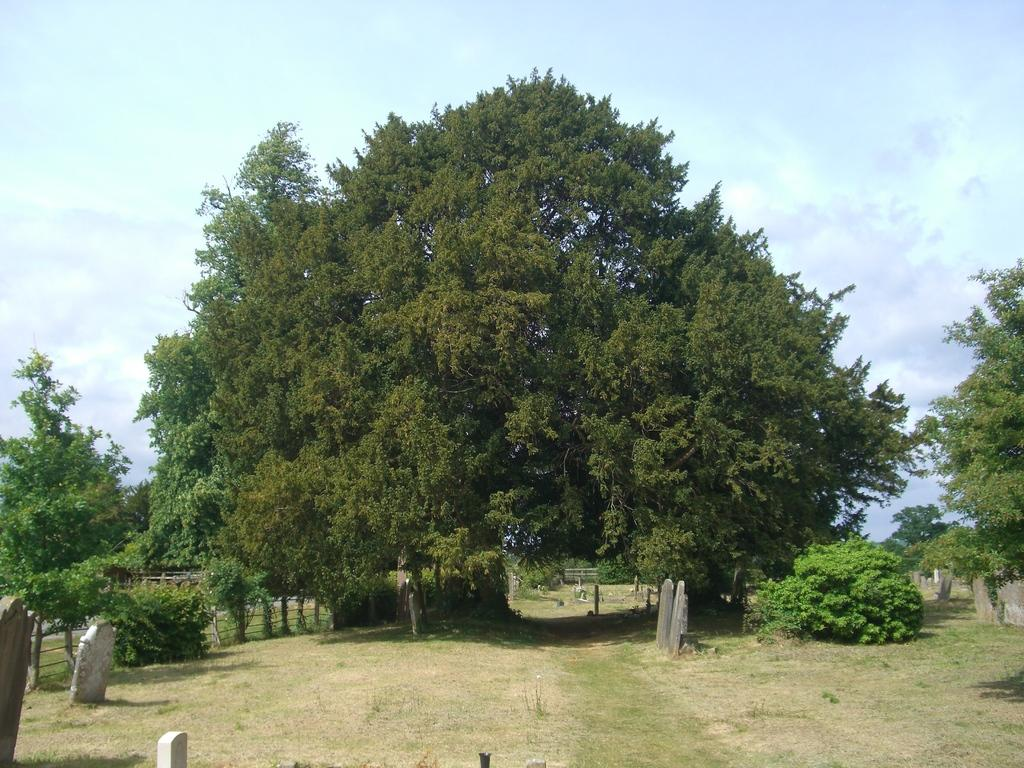What type of natural elements can be seen in the image? There are trees and plants in the image. What objects in the image resemble gravestones? There are stones that resemble gravestones in the image. What is visible at the top of the image? The sky is visible at the top of the image. What type of bun is being prepared by the cook in the image? There is no cook or bun present in the image. What type of laborer can be seen working in the image? There is no laborer present in the image. 